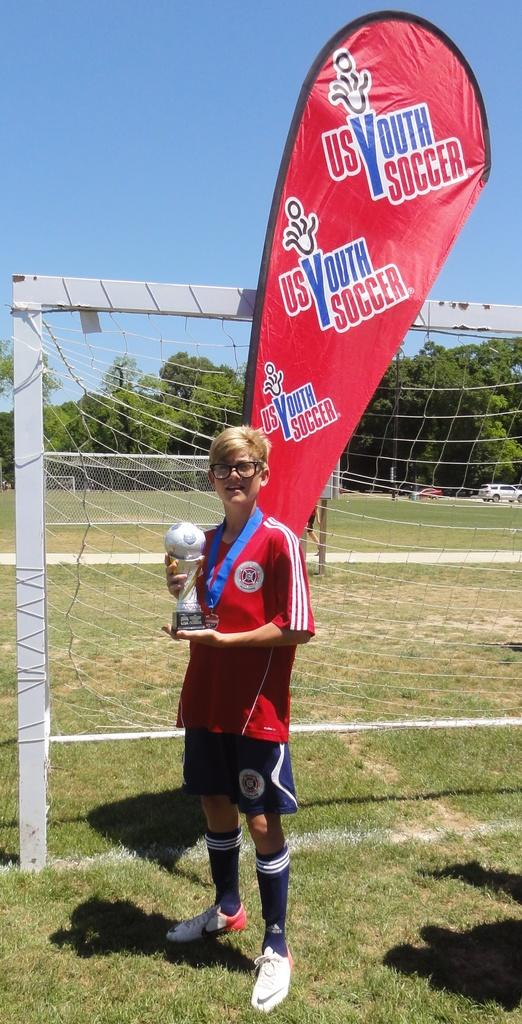<image>
Give a short and clear explanation of the subsequent image. Boy standing in front of a banner which says US Youth Soccer. 